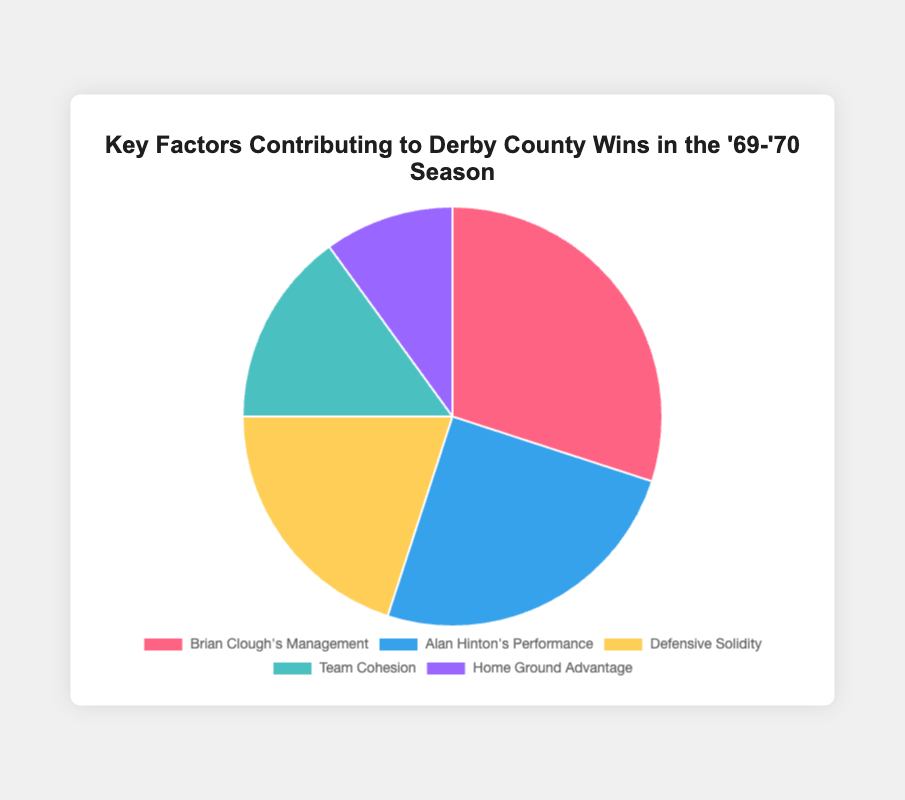What percentage of the factors contributing to Derby County wins is attributed to "Brian Clough's Management"? To find this, we simply refer to the pie chart and look for the percentage allocated to "Brian Clough's Management." According to the chart, this factor is labeled with 30%.
Answer: 30% How many more percentage points is "Brian Clough's Management" than "Home Ground Advantage"? First, we locate "Brian Clough's Management" (30%) and "Home Ground Advantage" (10%) in the pie chart. Then, we subtract the percentage of "Home Ground Advantage" from "Brian Clough's Management" (30% - 10% = 20%).
Answer: 20% Which factor has the second-largest percentage contribution? By referring to the pie chart, we arrange the factors by their percentages in descending order. The largest is "Brian Clough's Management" at 30%, followed by "Alan Hinton's Performance" at 25%. So, "Alan Hinton's Performance" is the second-largest factor.
Answer: Alan Hinton's Performance What is the total percentage contribution of "Defensive Solidity" and "Team Cohesion"? We first find the percentages for "Defensive Solidity" (20%) and "Team Cohesion" (15%) on the pie chart. Adding them together gives us 20% + 15% = 35%.
Answer: 35% Which factor has the smallest contribution, and what is its percentage? According to the pie chart, we look for the smallest percentage slice, which is "Home Ground Advantage" at 10%.
Answer: Home Ground Advantage, 10% How much larger is the total contribution of "Brian Clough's Management" and "Alan Hinton's Performance" compared to "Team Cohesion"? First, sum the percentages of "Brian Clough's Management" (30%) and "Alan Hinton's Performance" (25%) to get 55%. Compare this to "Team Cohesion" (15%) by subtracting 15% from 55% (55% - 15% = 40%).
Answer: 40% If you combine "Defensive Solidity," "Team Cohesion," and "Home Ground Advantage," what is their total contribution? Adding the percentages of "Defensive Solidity" (20%), "Team Cohesion" (15%), and "Home Ground Advantage" (10%) gives us 20% + 15% + 10% = 45%.
Answer: 45% What's the visual color of the slice representing "Alan Hinton's Performance"? By referring to the visual attributes of the pie chart, "Alan Hinton's Performance" is shown in a blue color.
Answer: Blue 